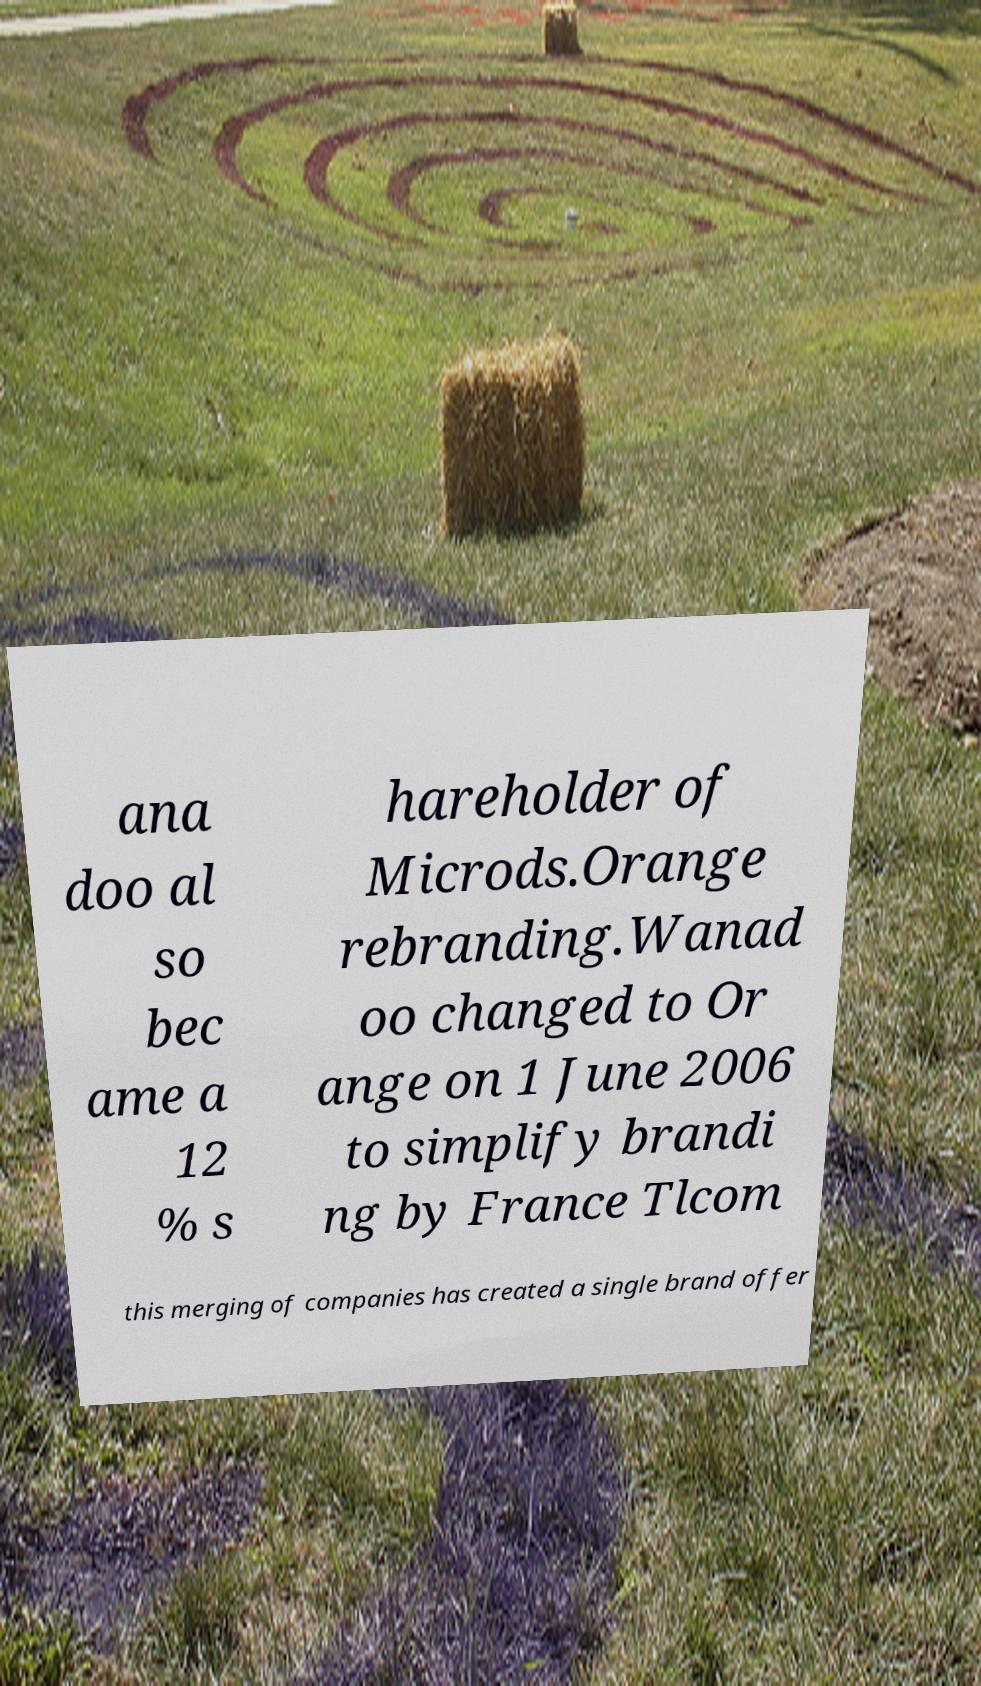Can you accurately transcribe the text from the provided image for me? ana doo al so bec ame a 12 % s hareholder of Microds.Orange rebranding.Wanad oo changed to Or ange on 1 June 2006 to simplify brandi ng by France Tlcom this merging of companies has created a single brand offer 